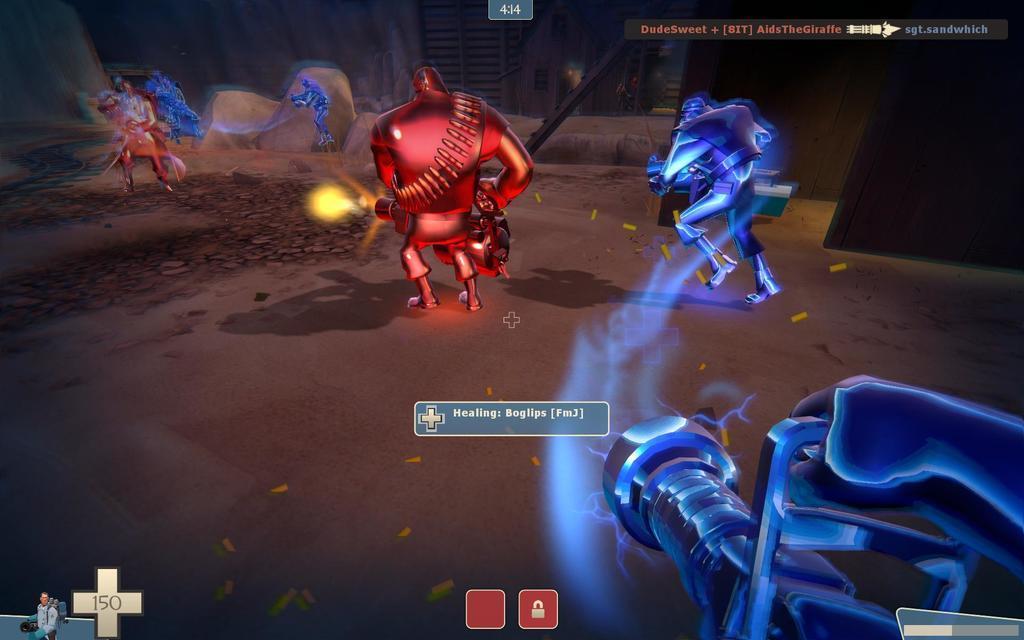How would you summarize this image in a sentence or two? This is an animated picture. We can see some information, people and few objects. 